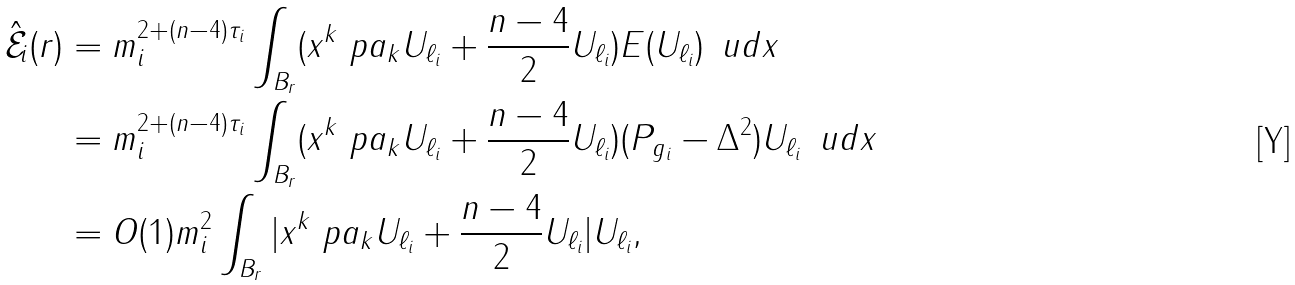<formula> <loc_0><loc_0><loc_500><loc_500>\mathcal { \hat { E } } _ { i } ( r ) & = m _ { i } ^ { 2 + ( n - 4 ) \tau _ { i } } \int _ { B _ { r } } ( x ^ { k } \ p a _ { k } U _ { \ell _ { i } } + \frac { n - 4 } { 2 } U _ { \ell _ { i } } ) E ( U _ { \ell _ { i } } ) \, \ u d x \\ & = m _ { i } ^ { 2 + ( n - 4 ) \tau _ { i } } \int _ { B _ { r } } ( x ^ { k } \ p a _ { k } U _ { \ell _ { i } } + \frac { n - 4 } { 2 } U _ { \ell _ { i } } ) ( P _ { g _ { i } } - \Delta ^ { 2 } ) U _ { \ell _ { i } } \, \ u d x \\ & = O ( 1 ) m _ { i } ^ { 2 } \int _ { B _ { r } } | x ^ { k } \ p a _ { k } U _ { \ell _ { i } } + \frac { n - 4 } { 2 } U _ { \ell _ { i } } | U _ { \ell _ { i } } ,</formula> 